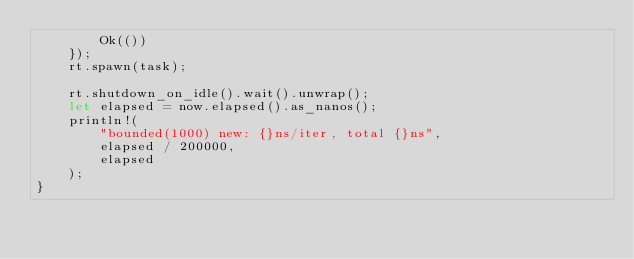Convert code to text. <code><loc_0><loc_0><loc_500><loc_500><_Rust_>        Ok(())
    });
    rt.spawn(task);

    rt.shutdown_on_idle().wait().unwrap();
    let elapsed = now.elapsed().as_nanos();
    println!(
        "bounded(1000) new: {}ns/iter, total {}ns",
        elapsed / 200000,
        elapsed
    );
}
</code> 